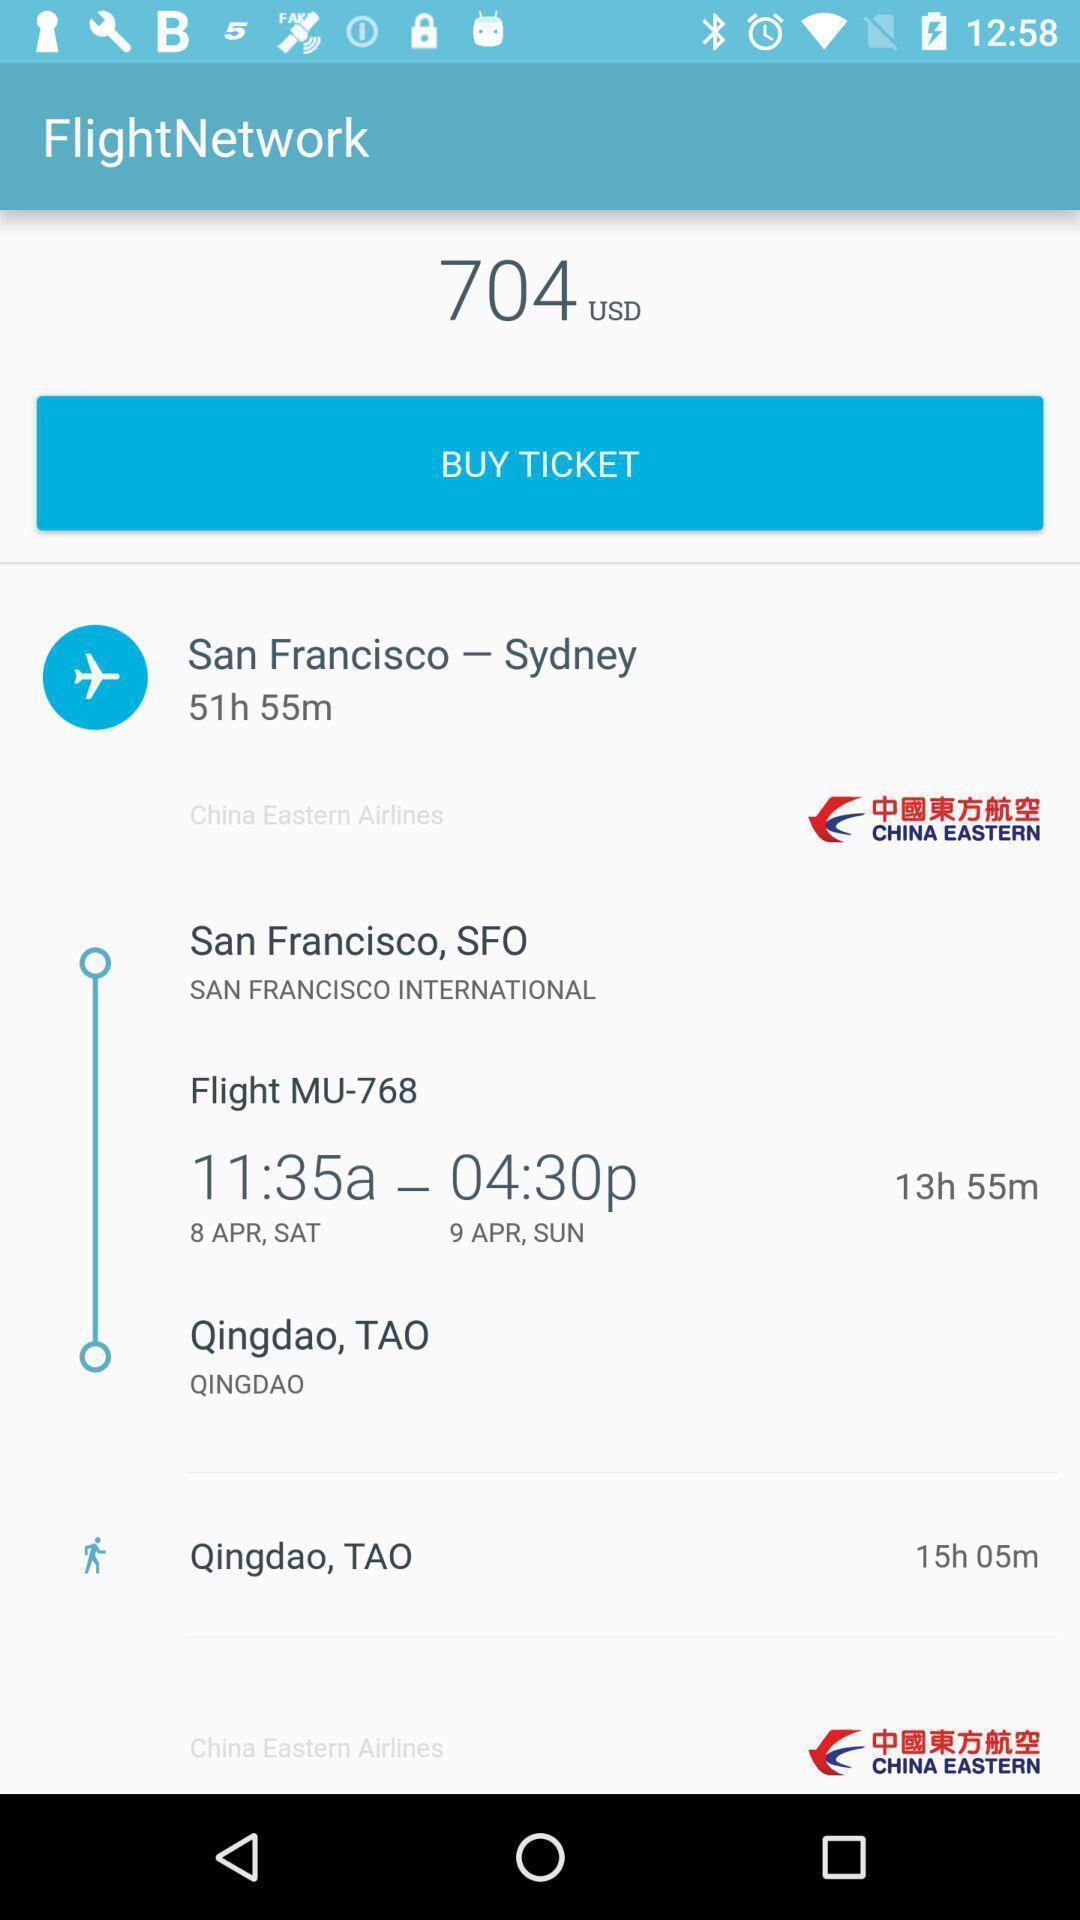Give me a narrative description of this picture. Page of a air transport service app. 